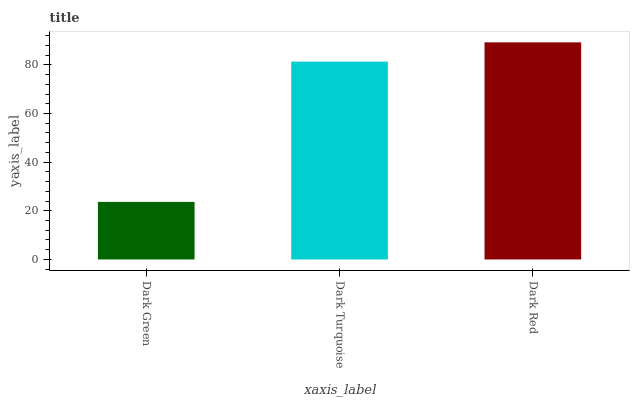Is Dark Green the minimum?
Answer yes or no. Yes. Is Dark Red the maximum?
Answer yes or no. Yes. Is Dark Turquoise the minimum?
Answer yes or no. No. Is Dark Turquoise the maximum?
Answer yes or no. No. Is Dark Turquoise greater than Dark Green?
Answer yes or no. Yes. Is Dark Green less than Dark Turquoise?
Answer yes or no. Yes. Is Dark Green greater than Dark Turquoise?
Answer yes or no. No. Is Dark Turquoise less than Dark Green?
Answer yes or no. No. Is Dark Turquoise the high median?
Answer yes or no. Yes. Is Dark Turquoise the low median?
Answer yes or no. Yes. Is Dark Red the high median?
Answer yes or no. No. Is Dark Green the low median?
Answer yes or no. No. 